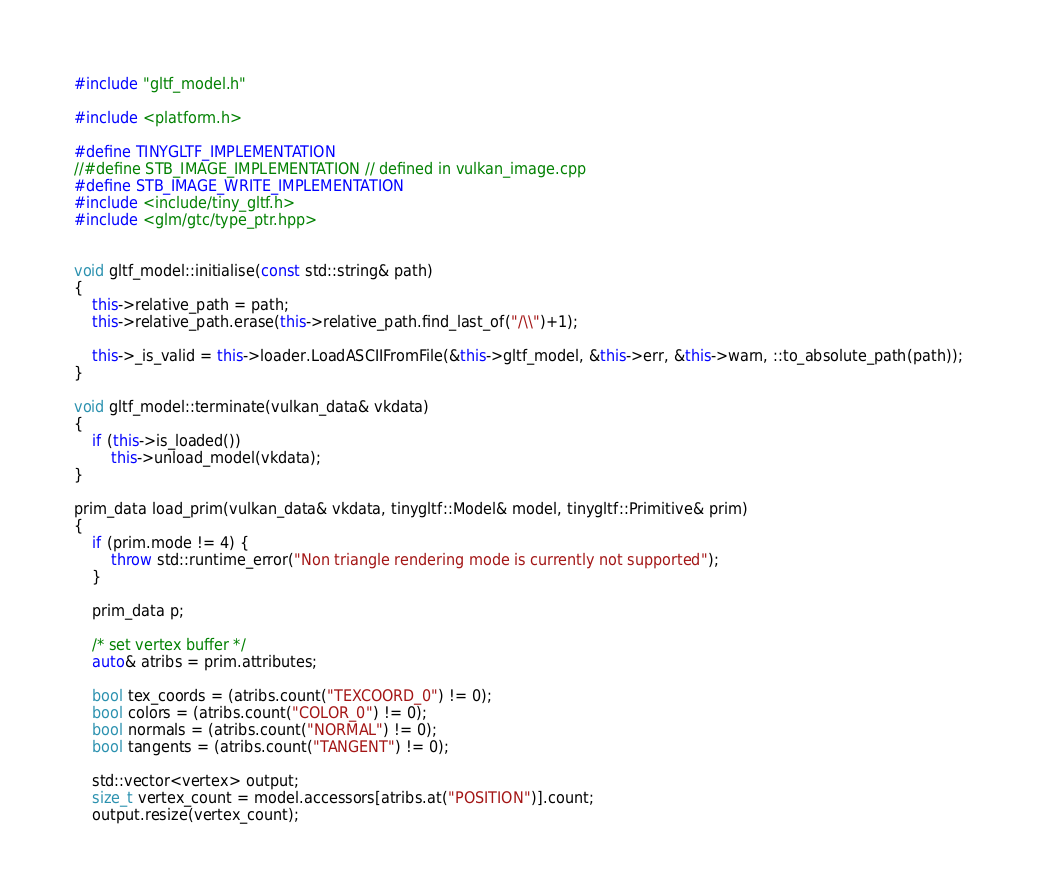<code> <loc_0><loc_0><loc_500><loc_500><_C++_>#include "gltf_model.h"

#include <platform.h>

#define TINYGLTF_IMPLEMENTATION
//#define STB_IMAGE_IMPLEMENTATION // defined in vulkan_image.cpp
#define STB_IMAGE_WRITE_IMPLEMENTATION
#include <include/tiny_gltf.h>
#include <glm/gtc/type_ptr.hpp>


void gltf_model::initialise(const std::string& path)
{
    this->relative_path = path;
    this->relative_path.erase(this->relative_path.find_last_of("/\\")+1);

    this->_is_valid = this->loader.LoadASCIIFromFile(&this->gltf_model, &this->err, &this->warn, ::to_absolute_path(path));
}

void gltf_model::terminate(vulkan_data& vkdata)
{
    if (this->is_loaded())
        this->unload_model(vkdata);
}

prim_data load_prim(vulkan_data& vkdata, tinygltf::Model& model, tinygltf::Primitive& prim)
{
    if (prim.mode != 4) {
        throw std::runtime_error("Non triangle rendering mode is currently not supported");
    }

    prim_data p;

    /* set vertex buffer */
    auto& atribs = prim.attributes;

    bool tex_coords = (atribs.count("TEXCOORD_0") != 0);
    bool colors = (atribs.count("COLOR_0") != 0);
    bool normals = (atribs.count("NORMAL") != 0);
    bool tangents = (atribs.count("TANGENT") != 0);

    std::vector<vertex> output;
    size_t vertex_count = model.accessors[atribs.at("POSITION")].count;
    output.resize(vertex_count);
</code> 